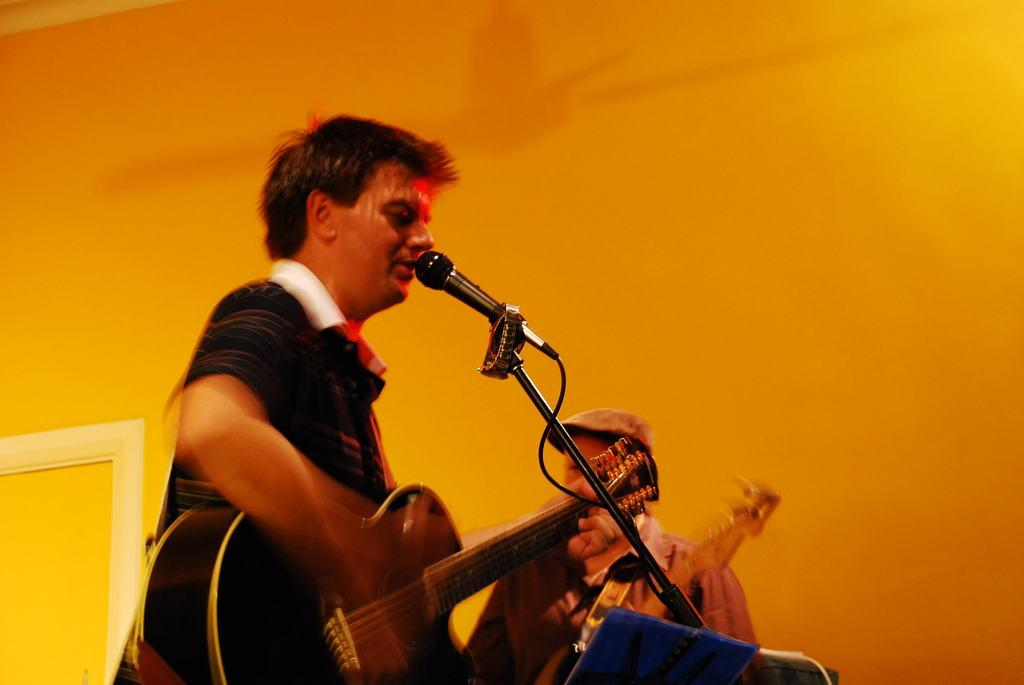How many people are in the image? There are two persons in the image. What is one of the persons holding? One of the persons is holding a guitar. What is the person holding the guitar standing near? The person holding the guitar is standing in front of a microphone. What can be seen in the background of the image? There is a wall in the background of the image. What is the color of the wall? The wall is orange in color. How many cherries are on the guitar in the image? There are no cherries present on the guitar in the image. What type of operation is being performed by the person holding the guitar? There is no operation being performed by the person holding the guitar; they are simply standing in front of a microphone. 